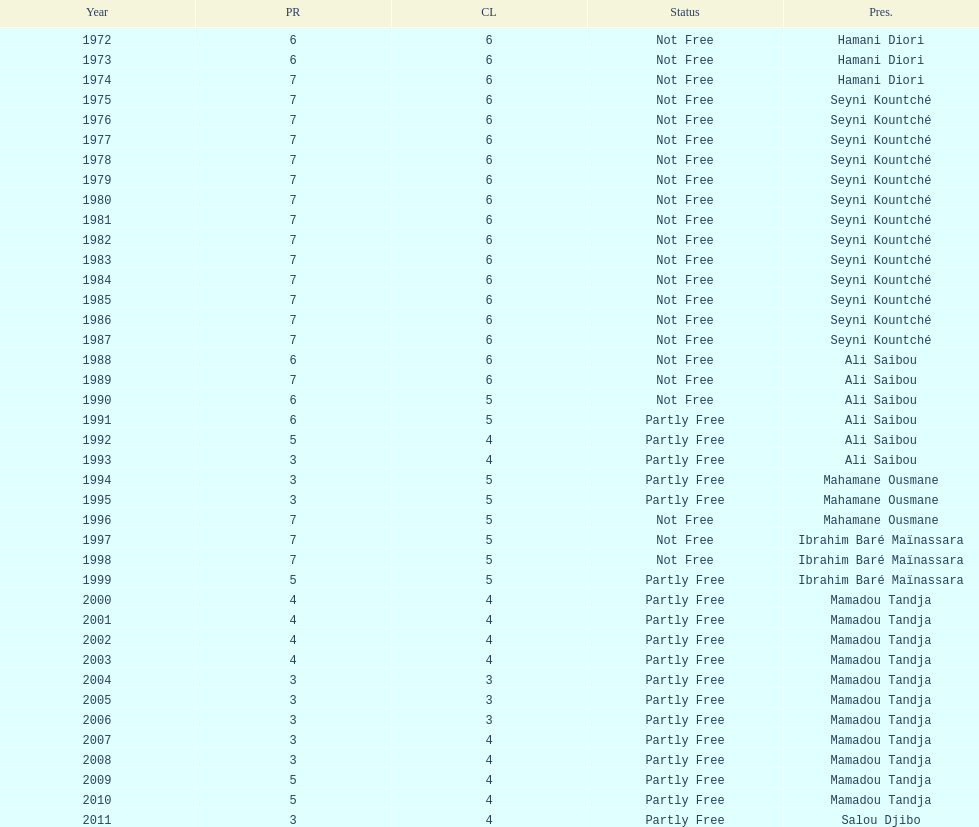Who is the next president listed after hamani diori in the year 1974? Seyni Kountché. Give me the full table as a dictionary. {'header': ['Year', 'PR', 'CL', 'Status', 'Pres.'], 'rows': [['1972', '6', '6', 'Not Free', 'Hamani Diori'], ['1973', '6', '6', 'Not Free', 'Hamani Diori'], ['1974', '7', '6', 'Not Free', 'Hamani Diori'], ['1975', '7', '6', 'Not Free', 'Seyni Kountché'], ['1976', '7', '6', 'Not Free', 'Seyni Kountché'], ['1977', '7', '6', 'Not Free', 'Seyni Kountché'], ['1978', '7', '6', 'Not Free', 'Seyni Kountché'], ['1979', '7', '6', 'Not Free', 'Seyni Kountché'], ['1980', '7', '6', 'Not Free', 'Seyni Kountché'], ['1981', '7', '6', 'Not Free', 'Seyni Kountché'], ['1982', '7', '6', 'Not Free', 'Seyni Kountché'], ['1983', '7', '6', 'Not Free', 'Seyni Kountché'], ['1984', '7', '6', 'Not Free', 'Seyni Kountché'], ['1985', '7', '6', 'Not Free', 'Seyni Kountché'], ['1986', '7', '6', 'Not Free', 'Seyni Kountché'], ['1987', '7', '6', 'Not Free', 'Seyni Kountché'], ['1988', '6', '6', 'Not Free', 'Ali Saibou'], ['1989', '7', '6', 'Not Free', 'Ali Saibou'], ['1990', '6', '5', 'Not Free', 'Ali Saibou'], ['1991', '6', '5', 'Partly Free', 'Ali Saibou'], ['1992', '5', '4', 'Partly Free', 'Ali Saibou'], ['1993', '3', '4', 'Partly Free', 'Ali Saibou'], ['1994', '3', '5', 'Partly Free', 'Mahamane Ousmane'], ['1995', '3', '5', 'Partly Free', 'Mahamane Ousmane'], ['1996', '7', '5', 'Not Free', 'Mahamane Ousmane'], ['1997', '7', '5', 'Not Free', 'Ibrahim Baré Maïnassara'], ['1998', '7', '5', 'Not Free', 'Ibrahim Baré Maïnassara'], ['1999', '5', '5', 'Partly Free', 'Ibrahim Baré Maïnassara'], ['2000', '4', '4', 'Partly Free', 'Mamadou Tandja'], ['2001', '4', '4', 'Partly Free', 'Mamadou Tandja'], ['2002', '4', '4', 'Partly Free', 'Mamadou Tandja'], ['2003', '4', '4', 'Partly Free', 'Mamadou Tandja'], ['2004', '3', '3', 'Partly Free', 'Mamadou Tandja'], ['2005', '3', '3', 'Partly Free', 'Mamadou Tandja'], ['2006', '3', '3', 'Partly Free', 'Mamadou Tandja'], ['2007', '3', '4', 'Partly Free', 'Mamadou Tandja'], ['2008', '3', '4', 'Partly Free', 'Mamadou Tandja'], ['2009', '5', '4', 'Partly Free', 'Mamadou Tandja'], ['2010', '5', '4', 'Partly Free', 'Mamadou Tandja'], ['2011', '3', '4', 'Partly Free', 'Salou Djibo']]} 